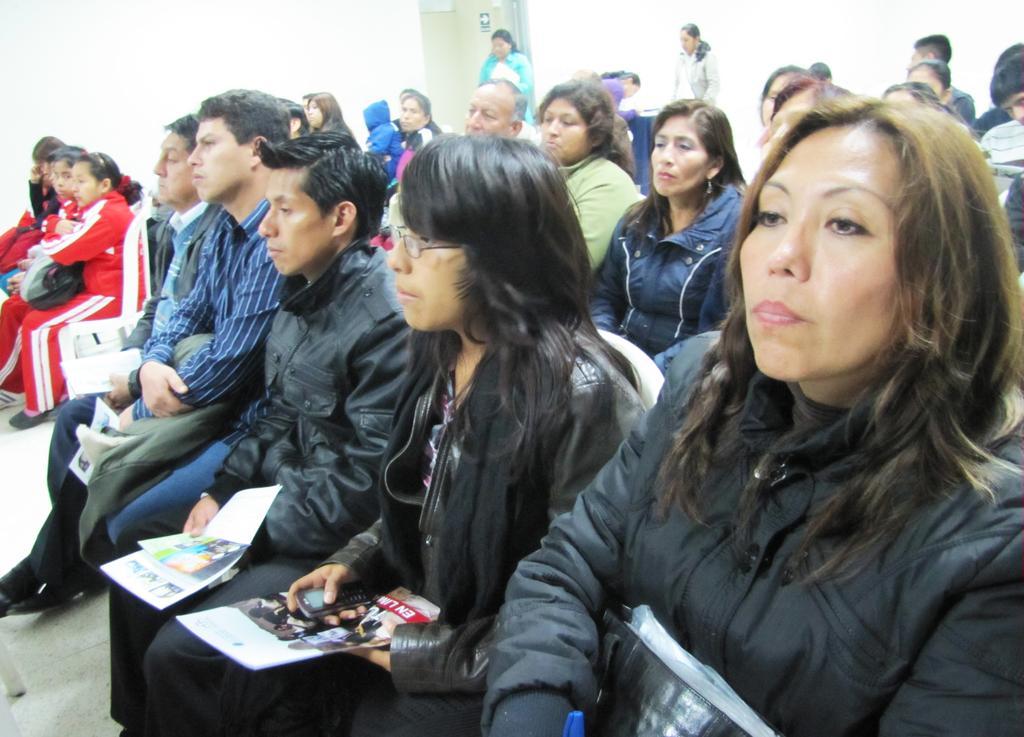Please provide a concise description of this image. In this image few persons are sitting on the chair. A woman wearing a black jacket is holding a mobile and a book in her hand. Beside there is a woman having a bag. A person wearing a blue shirt is holding clothes. Top of image few persons are standing beside the door. 